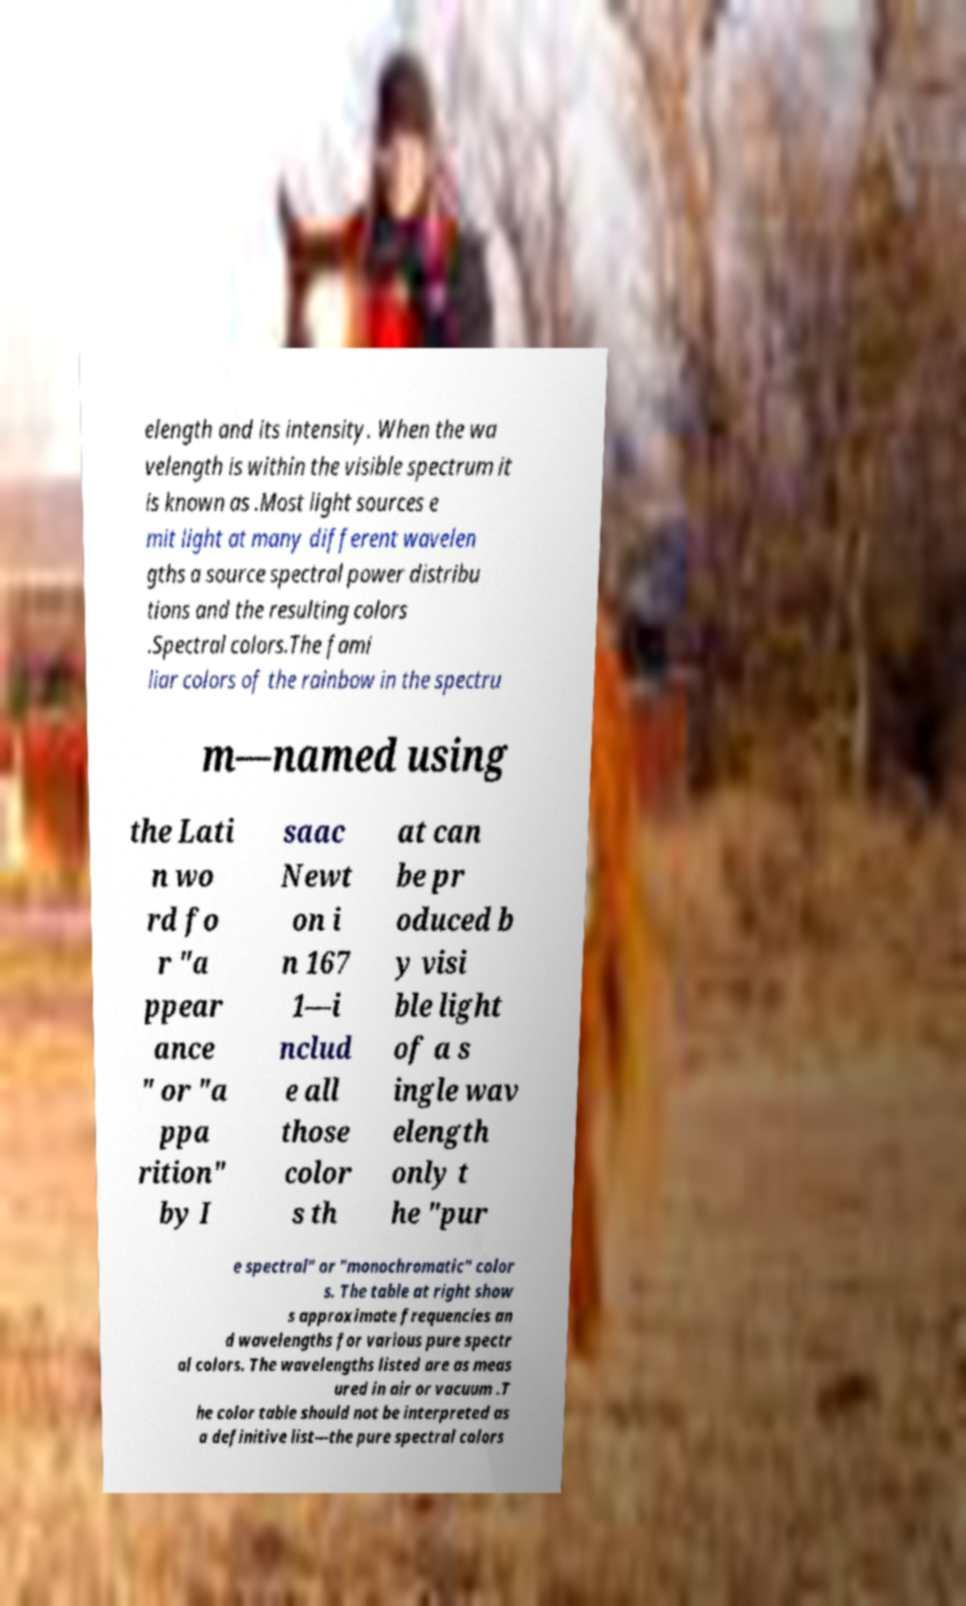Please identify and transcribe the text found in this image. elength and its intensity. When the wa velength is within the visible spectrum it is known as .Most light sources e mit light at many different wavelen gths a source spectral power distribu tions and the resulting colors .Spectral colors.The fami liar colors of the rainbow in the spectru m—named using the Lati n wo rd fo r "a ppear ance " or "a ppa rition" by I saac Newt on i n 167 1—i nclud e all those color s th at can be pr oduced b y visi ble light of a s ingle wav elength only t he "pur e spectral" or "monochromatic" color s. The table at right show s approximate frequencies an d wavelengths for various pure spectr al colors. The wavelengths listed are as meas ured in air or vacuum .T he color table should not be interpreted as a definitive list—the pure spectral colors 